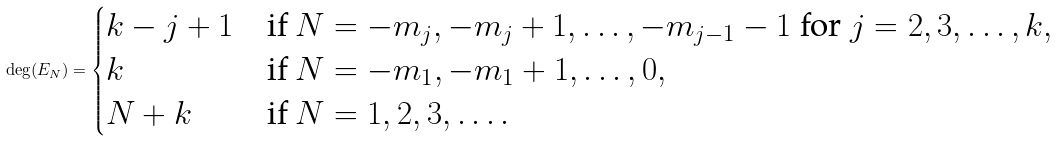<formula> <loc_0><loc_0><loc_500><loc_500>\deg ( E _ { N } ) = \begin{cases} k - j + 1 & \text {if $N=-m_{j},-m_{j}+1,\dots,-m_{j-1}-1$ for $j=2,3,\dots,k$} , \\ k & \text {if $N=-m_{1},-m_{1}+1,\dots,0$} , \\ N + k & \text {if $N=1,2,3,\dots$} . \\ \end{cases}</formula> 